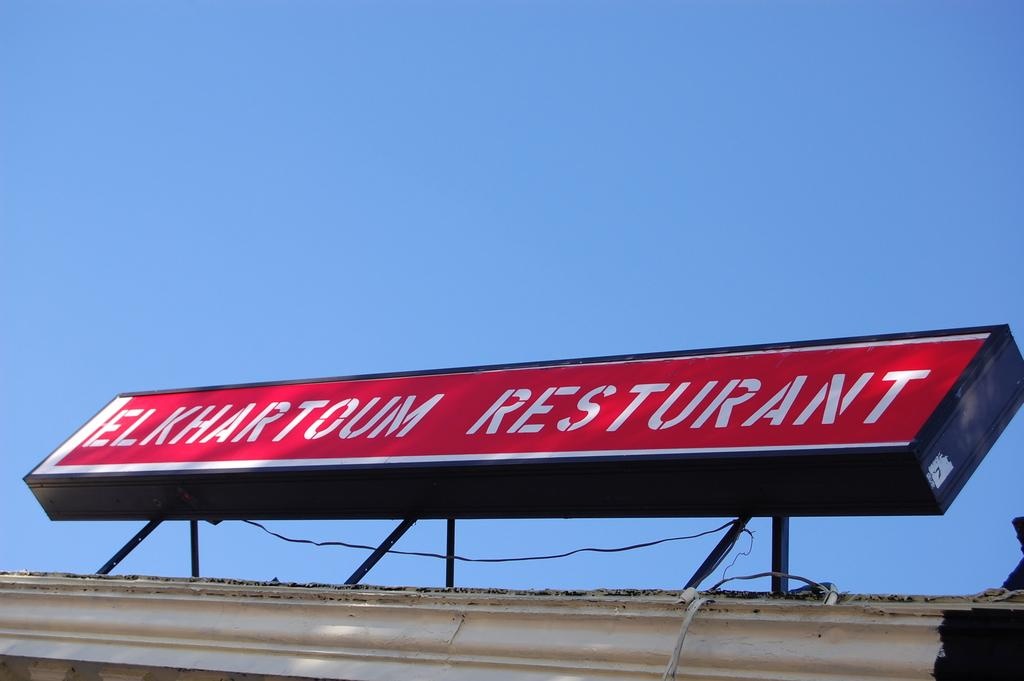Provide a one-sentence caption for the provided image. The Elkhartoum restaurant has a nice sign but it is misspelled. 